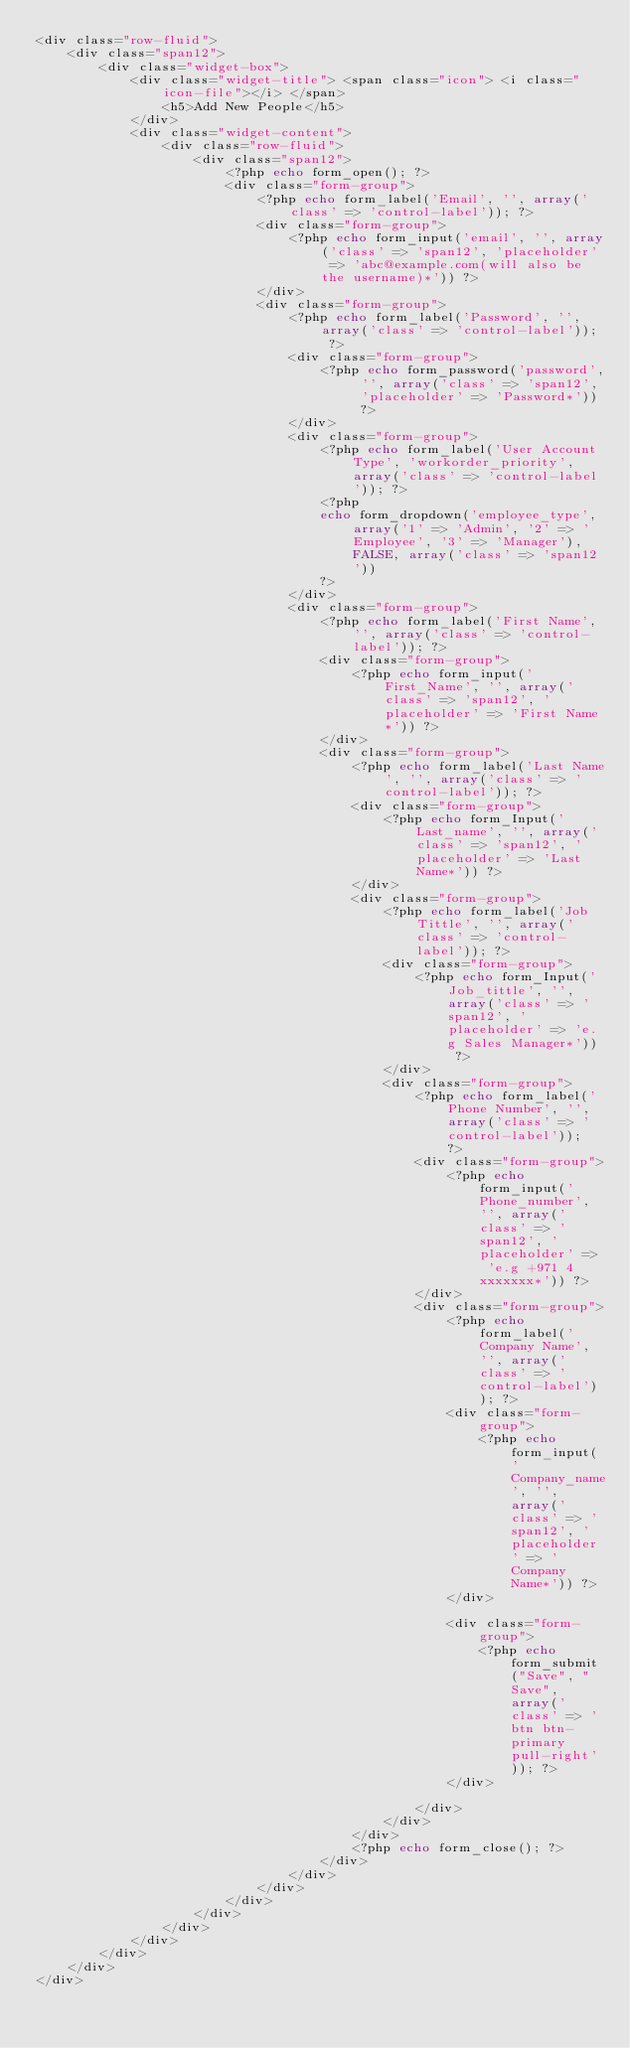Convert code to text. <code><loc_0><loc_0><loc_500><loc_500><_PHP_><div class="row-fluid">
    <div class="span12">
        <div class="widget-box"> 
            <div class="widget-title"> <span class="icon"> <i class="icon-file"></i> </span>
                <h5>Add New People</h5>
            </div>
            <div class="widget-content">
                <div class="row-fluid">
                    <div class="span12">
                        <?php echo form_open(); ?>
                        <div class="form-group">
                            <?php echo form_label('Email', '', array('class' => 'control-label')); ?>
                            <div class="form-group">
                                <?php echo form_input('email', '', array('class' => 'span12', 'placeholder' => 'abc@example.com(will also be the username)*')) ?>
                            </div>
                            <div class="form-group">
                                <?php echo form_label('Password', '', array('class' => 'control-label')); ?>
                                <div class="form-group">
                                    <?php echo form_password('password', '', array('class' => 'span12', 'placeholder' => 'Password*')) ?>
                                </div>
                                <div class="form-group">
                                    <?php echo form_label('User Account Type', 'workorder_priority', array('class' => 'control-label')); ?>
                                    <?php
                                    echo form_dropdown('employee_type', array('1' => 'Admin', '2' => 'Employee', '3' => 'Manager'), FALSE, array('class' => 'span12'))
                                    ?>
                                </div>   
                                <div class="form-group">
                                    <?php echo form_label('First Name', '', array('class' => 'control-label')); ?>
                                    <div class="form-group">
                                        <?php echo form_input('First_Name', '', array('class' => 'span12', 'placeholder' => 'First Name*')) ?>
                                    </div>
                                    <div class="form-group">
                                        <?php echo form_label('Last Name', '', array('class' => 'control-label')); ?>
                                        <div class="form-group">
                                            <?php echo form_Input('Last_name', '', array('class' => 'span12', 'placeholder' => 'Last Name*')) ?>
                                        </div>
                                        <div class="form-group">
                                            <?php echo form_label('Job Tittle', '', array('class' => 'control-label')); ?>
                                            <div class="form-group">
                                                <?php echo form_Input('Job_tittle', '', array('class' => 'span12', 'placeholder' => 'e.g Sales Manager*')) ?>
                                            </div>
                                            <div class="form-group">
                                                <?php echo form_label('Phone Number', '', array('class' => 'control-label')); ?>
                                                <div class="form-group">
                                                    <?php echo form_input('Phone_number', '', array('class' => 'span12', 'placeholder' => 'e.g +971 4 xxxxxxx*')) ?>
                                                </div>
                                                <div class="form-group">
                                                    <?php echo form_label('Company Name', '', array('class' => 'control-label')); ?>
                                                    <div class="form-group">
                                                        <?php echo form_input('Company_name', '', array('class' => 'span12', 'placeholder' => 'Company Name*')) ?>
                                                    </div>

                                                    <div class="form-group">
                                                        <?php echo form_submit("Save", "Save", array('class' => 'btn btn-primary pull-right')); ?>
                                                    </div>

                                                </div>
                                            </div>
                                        </div>
                                        <?php echo form_close(); ?>
                                    </div>
                                </div>
                            </div>
                        </div>
                    </div>
                </div>
            </div>
        </div>
    </div>
</div>

</code> 